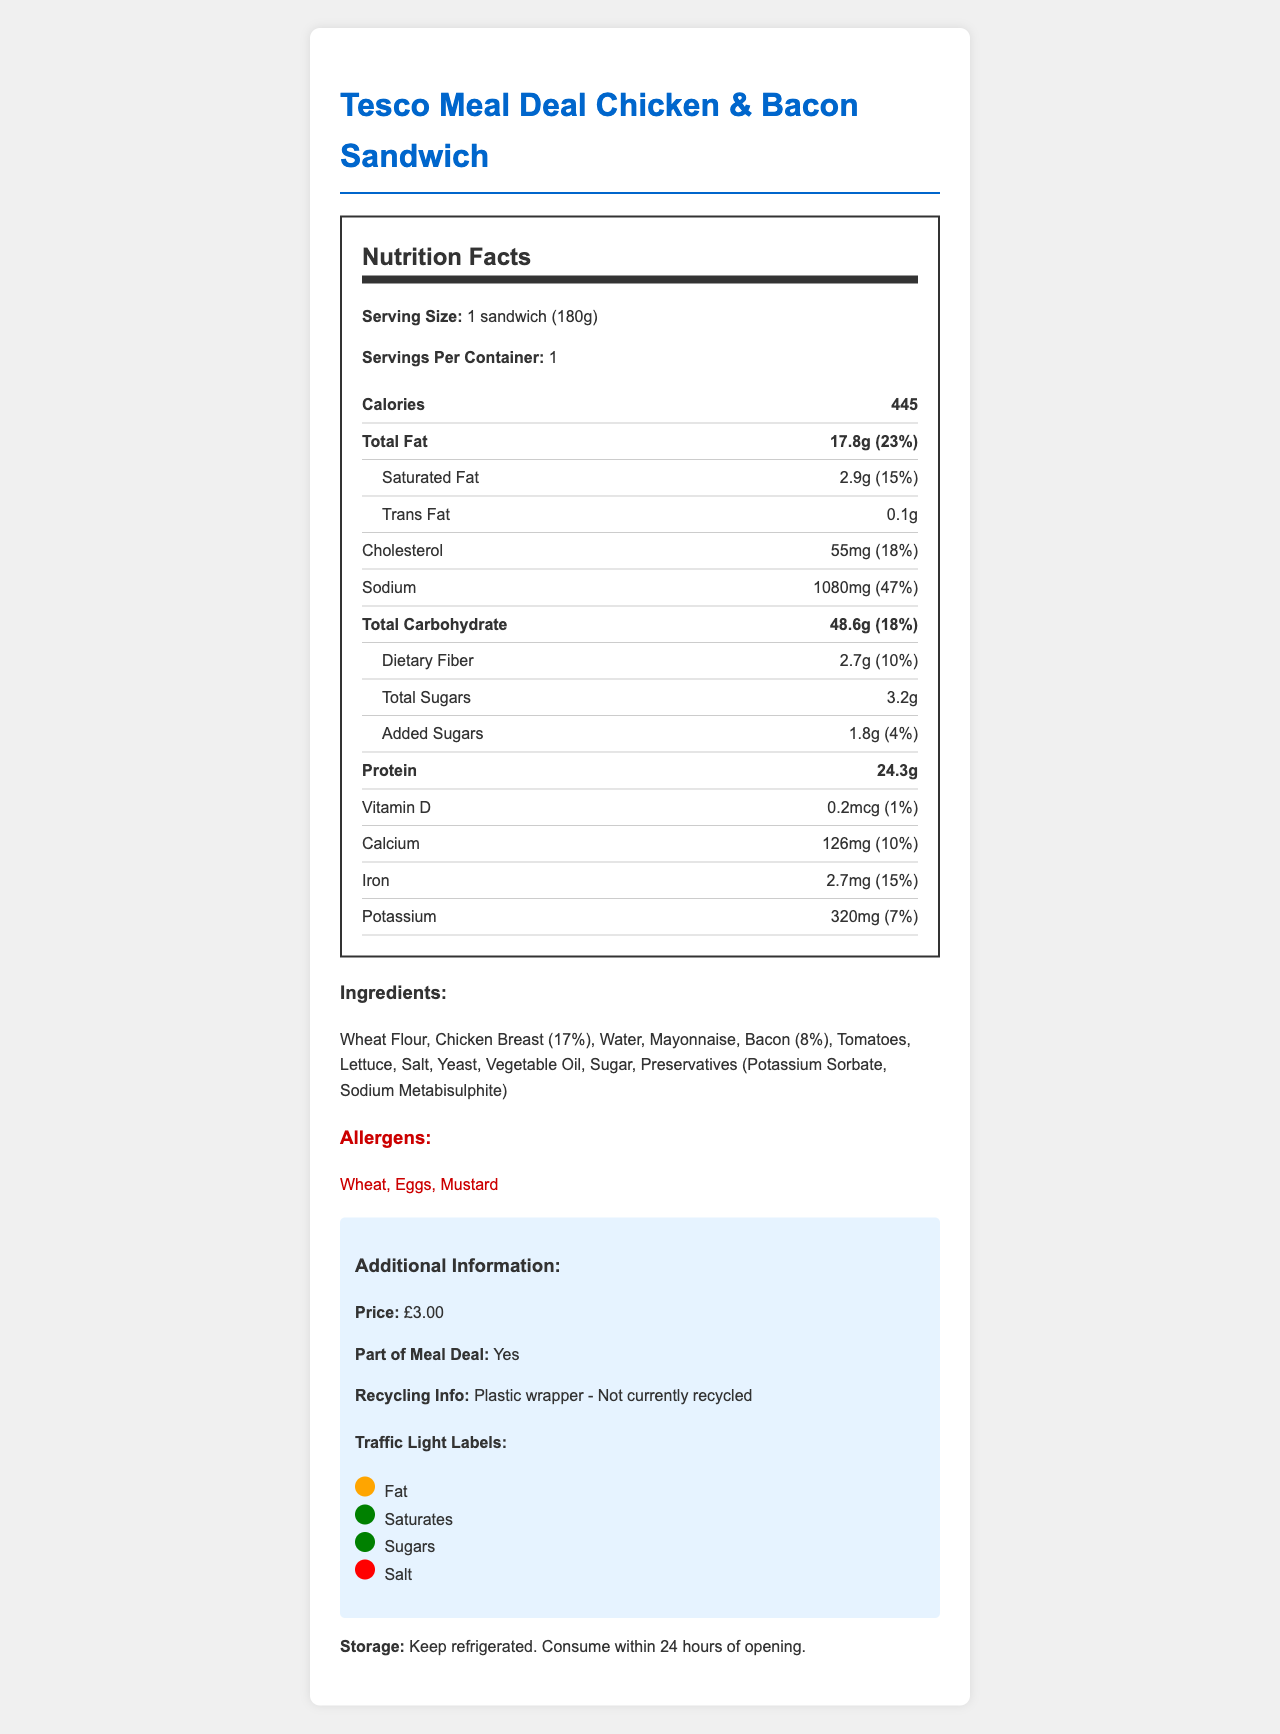what is the serving size of the sandwich? The serving size is stated as "1 sandwich (180g)" in the document.
Answer: 1 sandwich (180g) how many calories does one sandwich contain? The calories per serving (one sandwich) are listed as 445.
Answer: 445 what is the amount of total fat in the sandwich? The total fat content in the sandwich is noted as 17.8g.
Answer: 17.8g how much protein is in the sandwich? The protein content of the sandwich is given as 24.3g.
Answer: 24.3g which ingredient is present at 17% in the sandwich? Chicken Breast is listed as the ingredient present at 17%.
Answer: Chicken Breast how much saturated fat does the sandwich contain? The saturated fat content is stated as 2.9g.
Answer: 2.9g what is the price of the sandwich? The price of the sandwich is indicated as £3.00.
Answer: £3.00 how much sodium is in the sandwich? The sodium content in the sandwich is 1080mg.
Answer: 1080mg what is the daily value percentage of dietary fiber in the sandwich? The daily value percentage for dietary fiber is 10%.
Answer: 10% how should the sandwich be stored? The document specifies that the sandwich should be kept refrigerated and consumed within 24 hours of opening.
Answer: Keep refrigerated. Consume within 24 hours of opening. what allergens are present in the sandwich? The allergens listed are Wheat, Eggs, and Mustard.
Answer: Wheat, Eggs, Mustard is the sandwich part of a meal deal? The document indicates that the sandwich is part of a meal deal.
Answer: Yes is the plastic wrapper recyclable? The recycling info states "Plastic wrapper - Not currently recycled."
Answer: No what is the amount of added sugars in the sandwich? The added sugars in the sandwich are listed as 1.8g.
Answer: 1.8g how is the sandwich rated for salt in the traffic light labels? The traffic light label for salt is marked as "Red", indicating a high level.
Answer: Red which of the following ingredients is not listed in the sandwich? A. Yeast B. Pepper C. Bacon D. Tomatoes The ingredients listed do not include Pepper.
Answer: B. Pepper how much calcium is in the sandwich? The calcium content is given as 126mg.
Answer: 126mg which color is associated with fat in the traffic light labels? A. Red B. Amber C. Green The traffic light label for fat is amber.
Answer: B. Amber what percentage of daily value does the cholesterol content represent? The cholesterol content represents 18% of the daily value.
Answer: 18% what is the main idea of the document? The document is a comprehensive Nutrition Facts label for the sandwich, which includes various details about its nutritional content, ingredients, allergens, storage, price, recycling info, and traffic light labels.
Answer: The document provides a detailed Nutrition Facts label for a Tesco Meal Deal Chicken & Bacon Sandwich, including nutritional content, ingredients, allergens, storage information, and additional British-specific details like pricing and recycling information. what farming methods are used to produce the ingredients? The document does not provide any details about the farming methods used to produce the ingredients.
Answer: Not enough information 